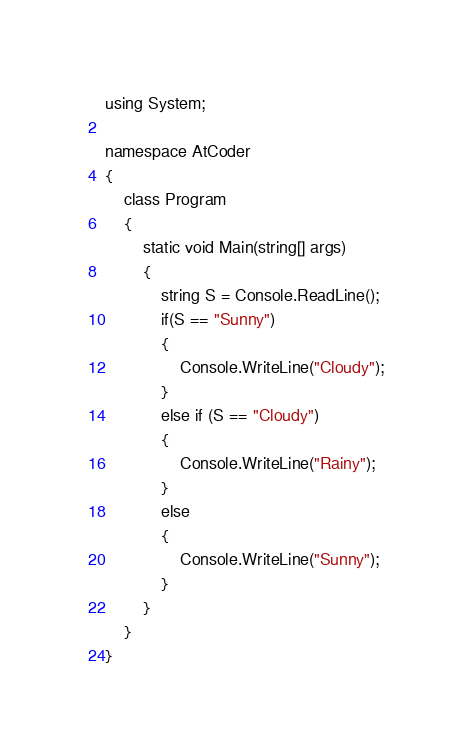Convert code to text. <code><loc_0><loc_0><loc_500><loc_500><_C#_>using System;

namespace AtCoder
{
    class Program
    {
        static void Main(string[] args)
        {
            string S = Console.ReadLine();
            if(S == "Sunny")
            {
                Console.WriteLine("Cloudy");
            }
            else if (S == "Cloudy")
            {
                Console.WriteLine("Rainy");
            }
            else
            {
                Console.WriteLine("Sunny");
            }
        }
    }
}
</code> 